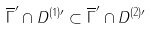<formula> <loc_0><loc_0><loc_500><loc_500>\overline { \Gamma } ^ { \prime } \cap D ^ { ( 1 ) \prime } \subset \overline { \Gamma } ^ { \prime } \cap D ^ { ( 2 ) \prime }</formula> 